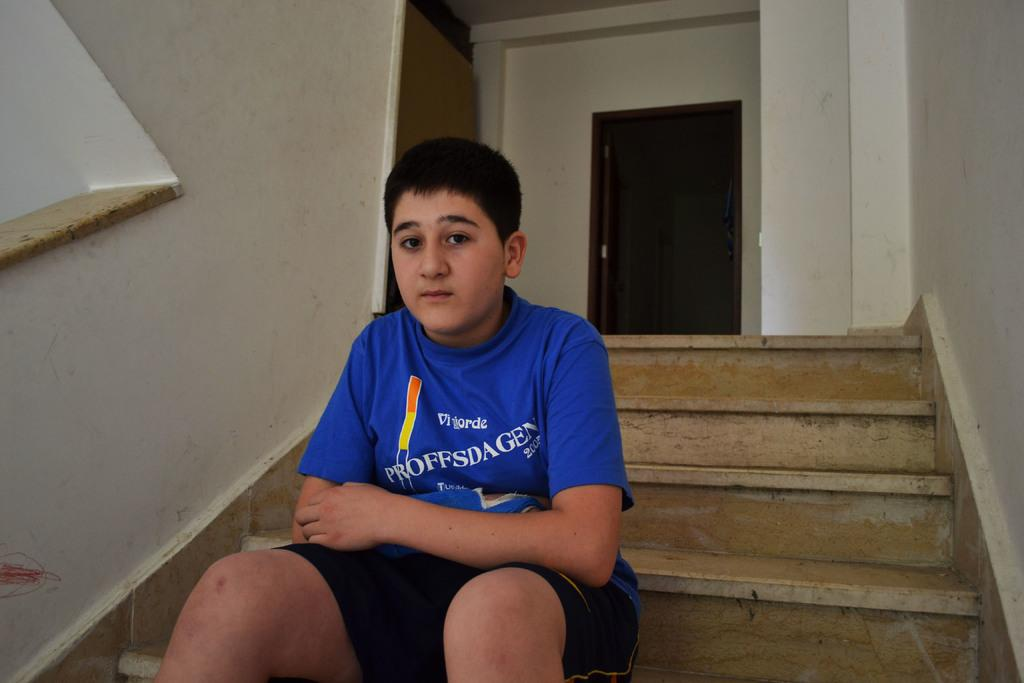<image>
Give a short and clear explanation of the subsequent image. A boy in a blue shirt that says Proffsdagen is sitting on steps. 